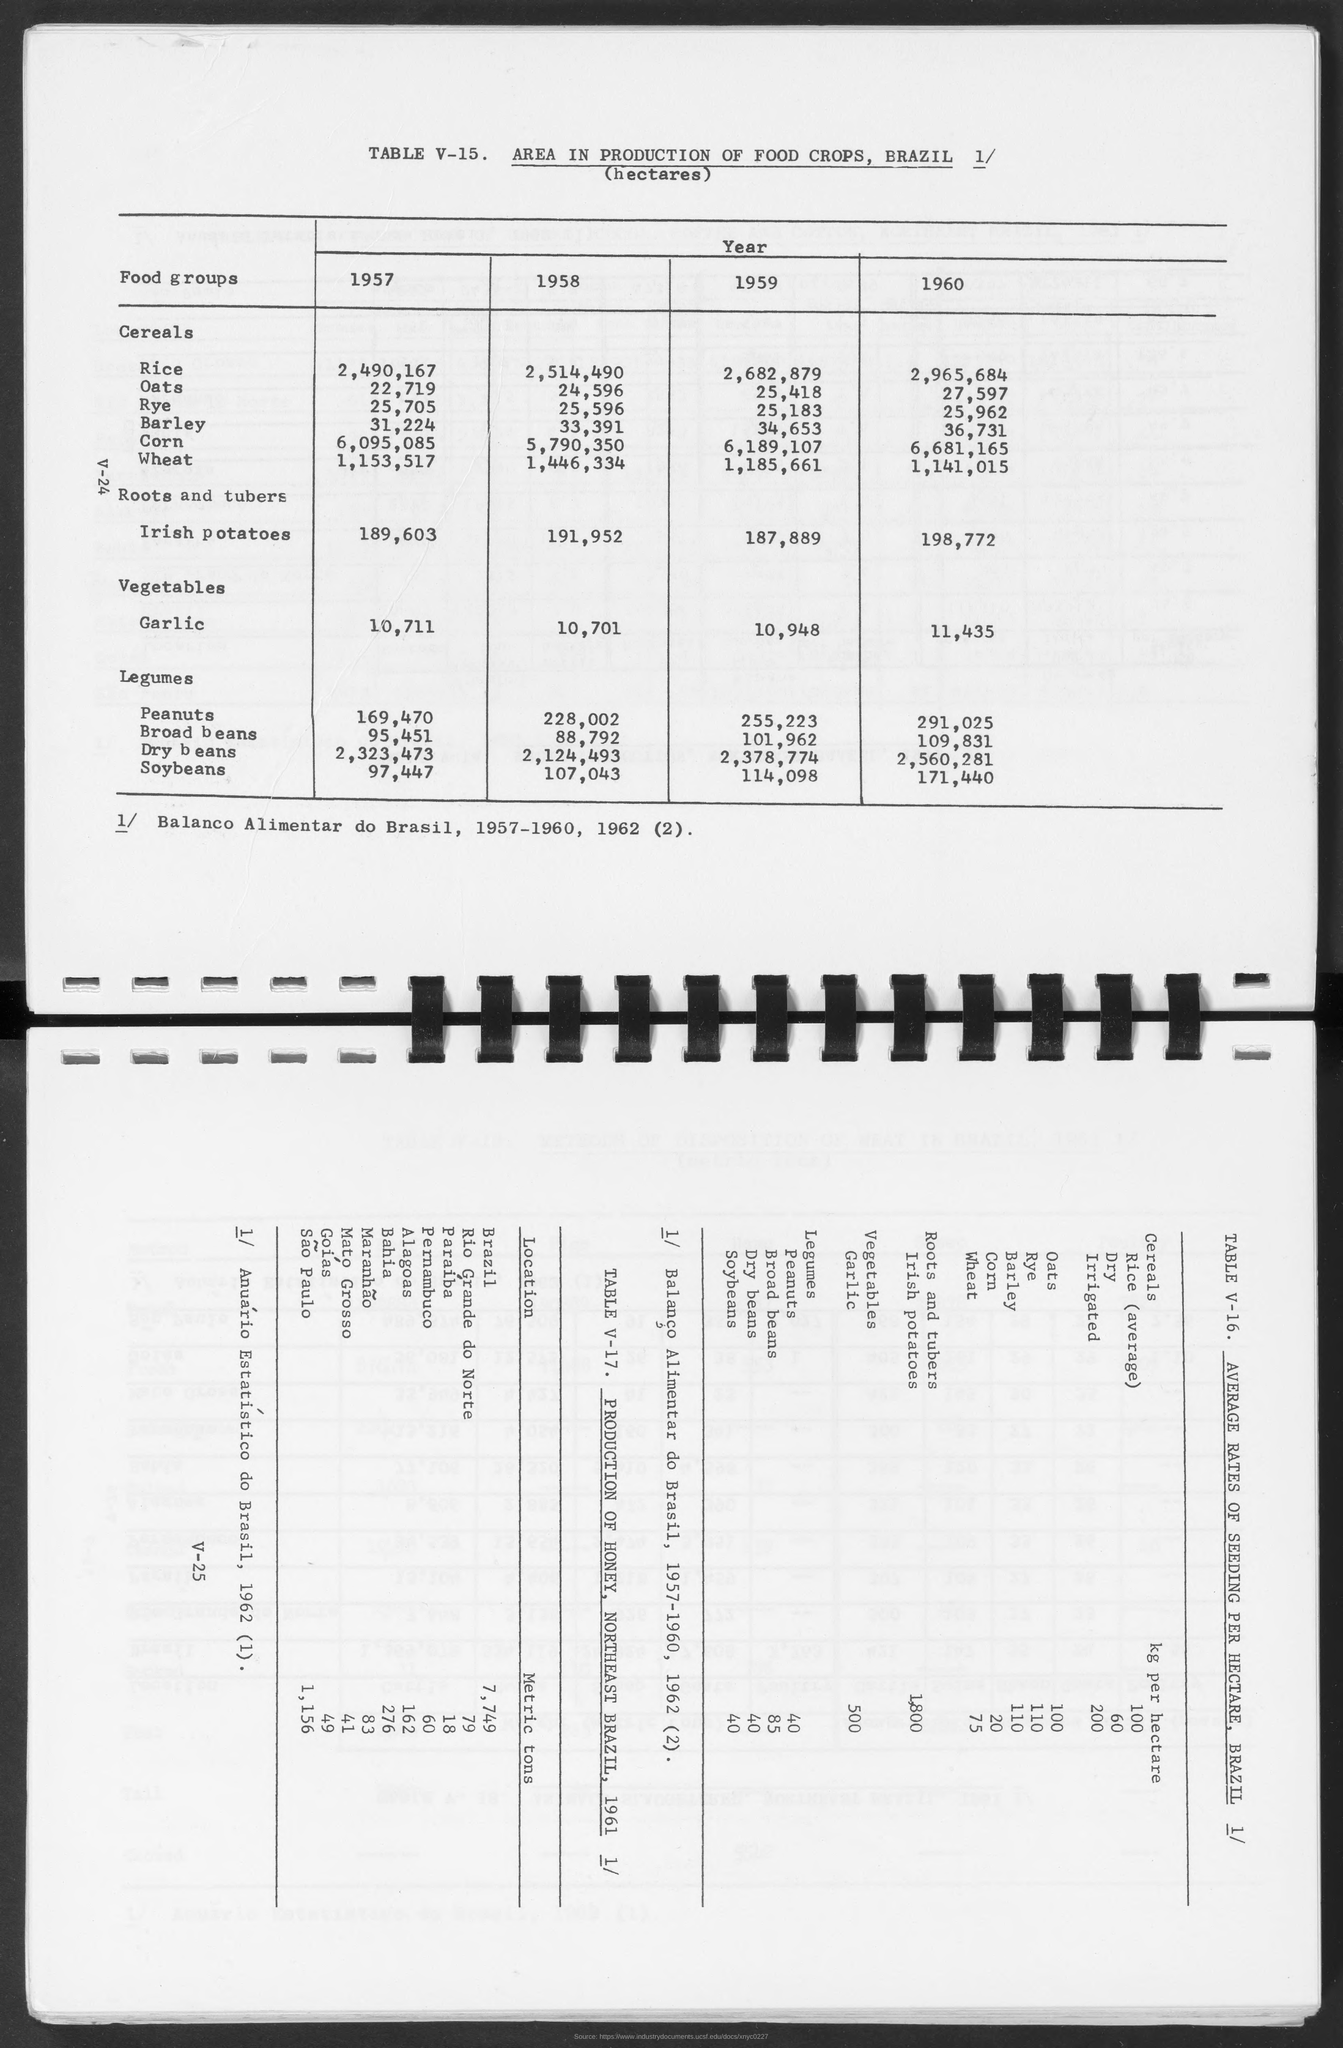Draw attention to some important aspects in this diagram. In 1957, there were approximately 22,719 hectares of oats. In 1959, there were 25,418 hectares of oats. In 1958, there were approximately 24,596 hectares of oats. In 1960, there were 27,597 hectares of oats. In 1958, there were 25,596 hectares of Rye produced. 